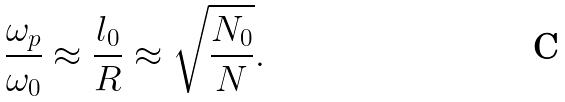<formula> <loc_0><loc_0><loc_500><loc_500>\frac { \omega _ { p } } { \omega _ { 0 } } \approx \frac { l _ { 0 } } { R } \approx \sqrt { \frac { N _ { 0 } } { N } } .</formula> 